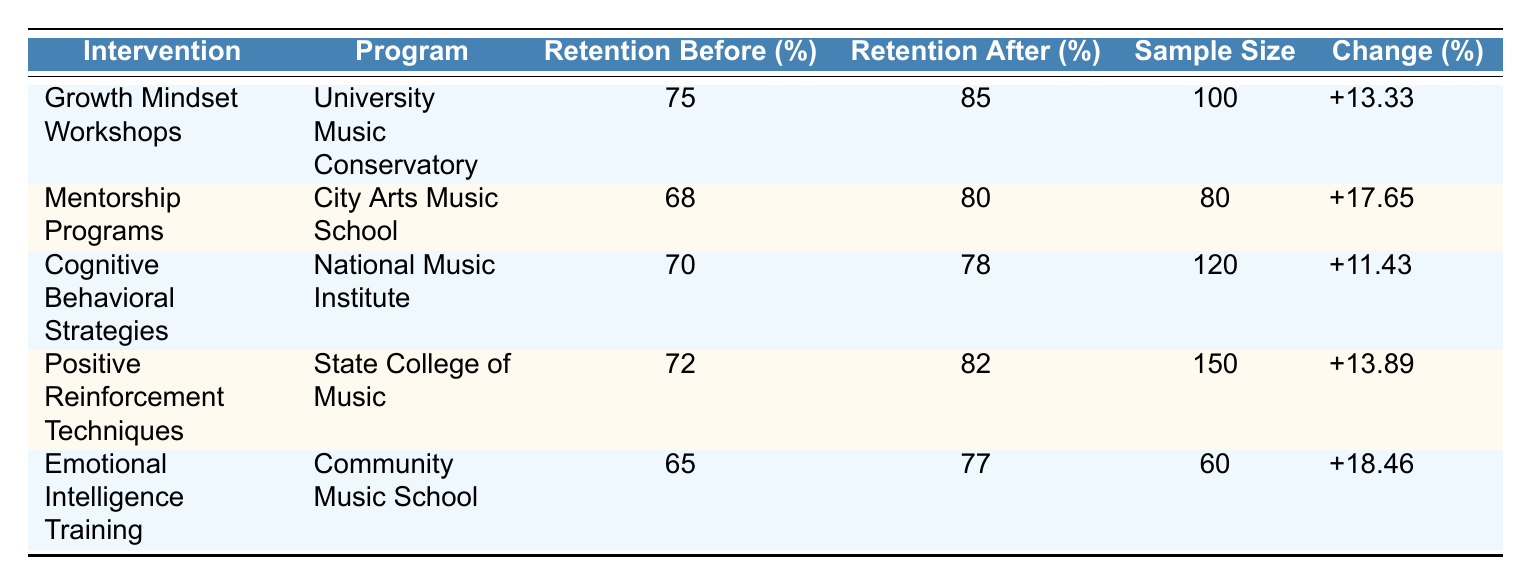What is the retention rate before the Growth Mindset Workshops? Referring to the table, the retention rate before this intervention is stated directly in the "Retention Before (%)" column for the "Growth Mindset Workshops." It shows 75%.
Answer: 75% Which intervention had the highest change in student retention percentage? By analyzing the "Change (%)" column in the table, we see that the "Emotional Intelligence Training" intervention shows a change of 18.46%, which is the highest among all listed interventions.
Answer: 18.46% What is the average retention rate after all interventions? To find the average, first sum the "Retention After (%)" values: (85 + 80 + 78 + 82 + 77) = 402. Next, divide this total by the number of interventions (5): 402 / 5 = 80.4.
Answer: 80.4 Did the Mentorship Programs have a higher retention rate after the intervention compared to the CBT Strategies? According to the table, the Mentorship Programs had a retention rate of 80% after the intervention, while the Cognitive Behavioral Strategies had a retention rate of 78%. Since 80% is greater than 78%, the statement is true.
Answer: Yes What is the total sample size for the Emotional Intelligence Training and Mentorship Programs combined? The sample size for Emotional Intelligence Training is 60 and for Mentorship Programs it is 80. Adding these together results in 60 + 80 = 140.
Answer: 140 Which program had the lowest student retention rate before the intervention? Checking the retention rates before the interventions, the table lists "Emotional Intelligence Training" at 65%, which is the lowest among all the programs listed.
Answer: 65% Did any intervention result in a change of less than 13% in student retention rates? By reviewing the "Change (%)" column, we see "Cognitive Behavioral Strategies" showing a change of 11.43%, which is less than 13%. Therefore, the answer is yes.
Answer: Yes What is the difference in student retention rates after the Growth Mindset Workshops and Positive Reinforcement Techniques? The retention rate after the Growth Mindset Workshops is 85%, and after Positive Reinforcement Techniques, it is 82%. The difference is calculated as 85 - 82 = 3.
Answer: 3 